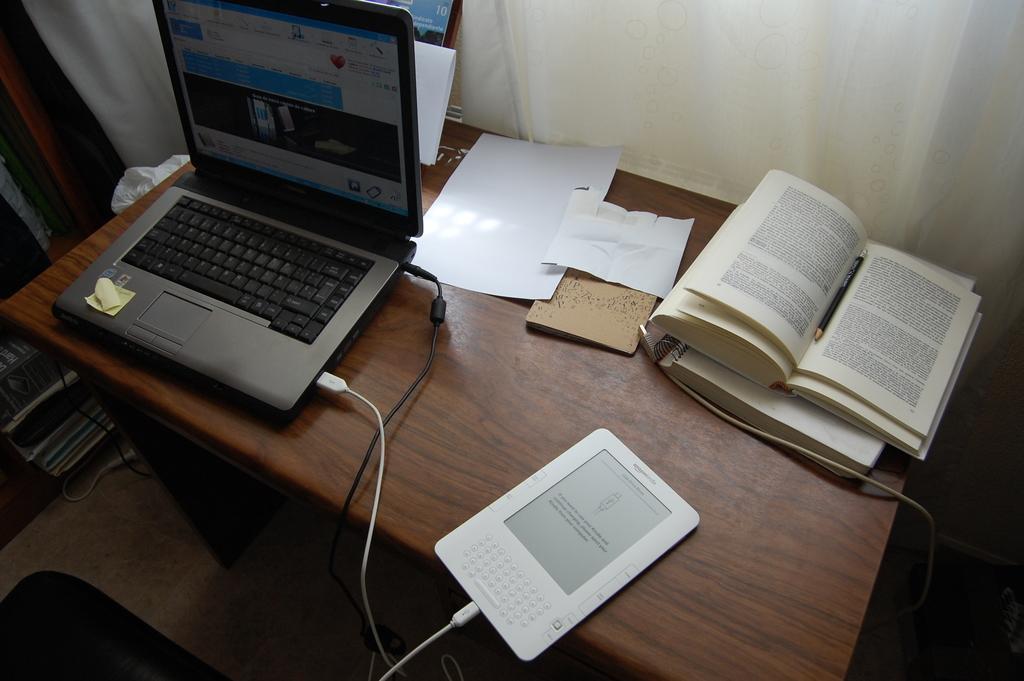In one or two sentences, can you explain what this image depicts? In the center we can see the table,on table we can see the laptop,book,tab etc. On the background we can see the curtain. 